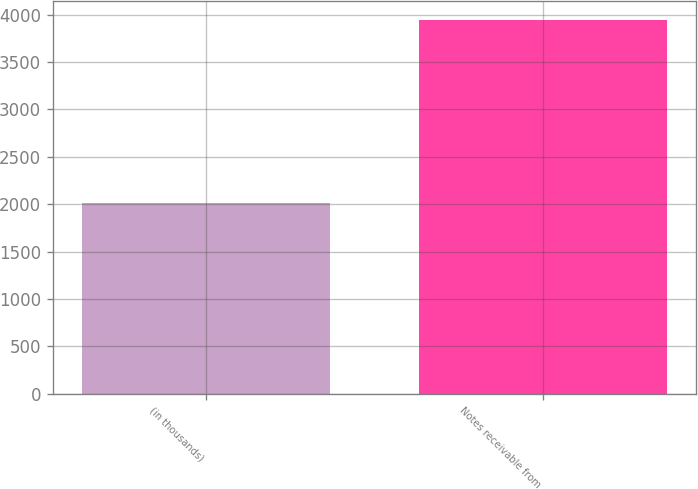Convert chart. <chart><loc_0><loc_0><loc_500><loc_500><bar_chart><fcel>(in thousands)<fcel>Notes receivable from<nl><fcel>2008<fcel>3947<nl></chart> 